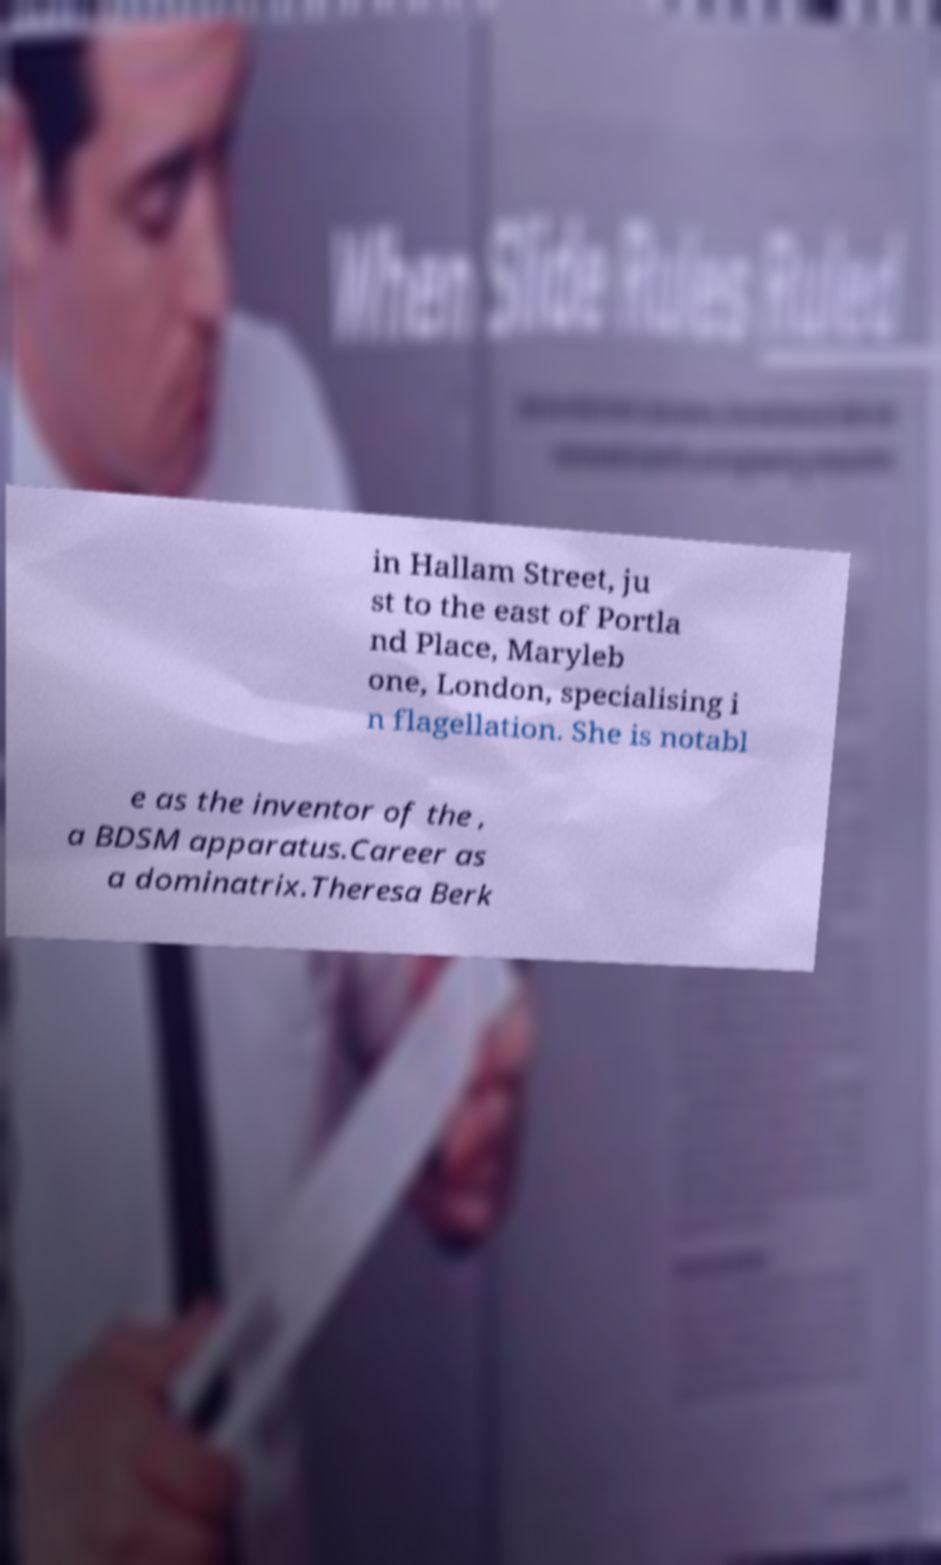Could you extract and type out the text from this image? in Hallam Street, ju st to the east of Portla nd Place, Maryleb one, London, specialising i n flagellation. She is notabl e as the inventor of the , a BDSM apparatus.Career as a dominatrix.Theresa Berk 